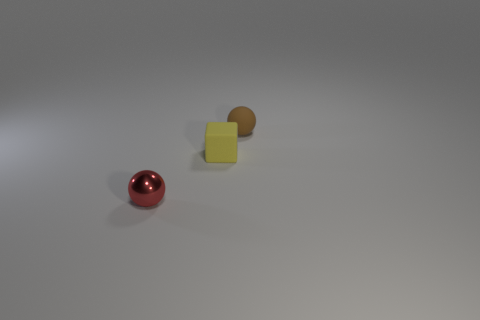Add 2 red spheres. How many objects exist? 5 Subtract all blocks. How many objects are left? 2 Subtract all yellow things. Subtract all tiny cylinders. How many objects are left? 2 Add 2 small yellow matte objects. How many small yellow matte objects are left? 3 Add 3 large gray objects. How many large gray objects exist? 3 Subtract 0 blue balls. How many objects are left? 3 